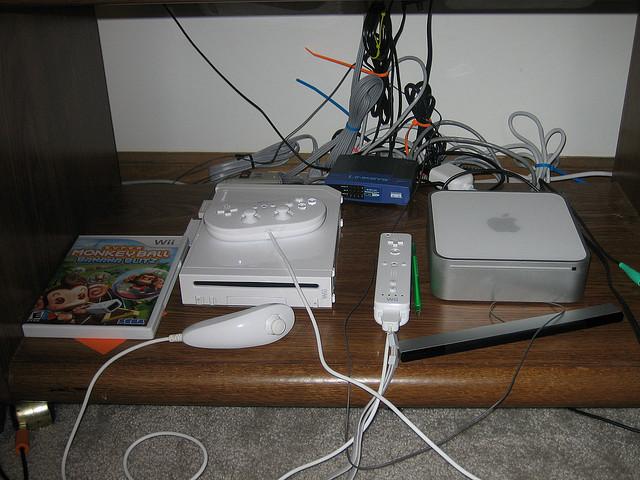What brand logo can you see?
Answer briefly. Apple. Why are there electronics in this photo?
Write a very short answer. To play. What do you call the controller in the middle?
Answer briefly. Wiimote. 